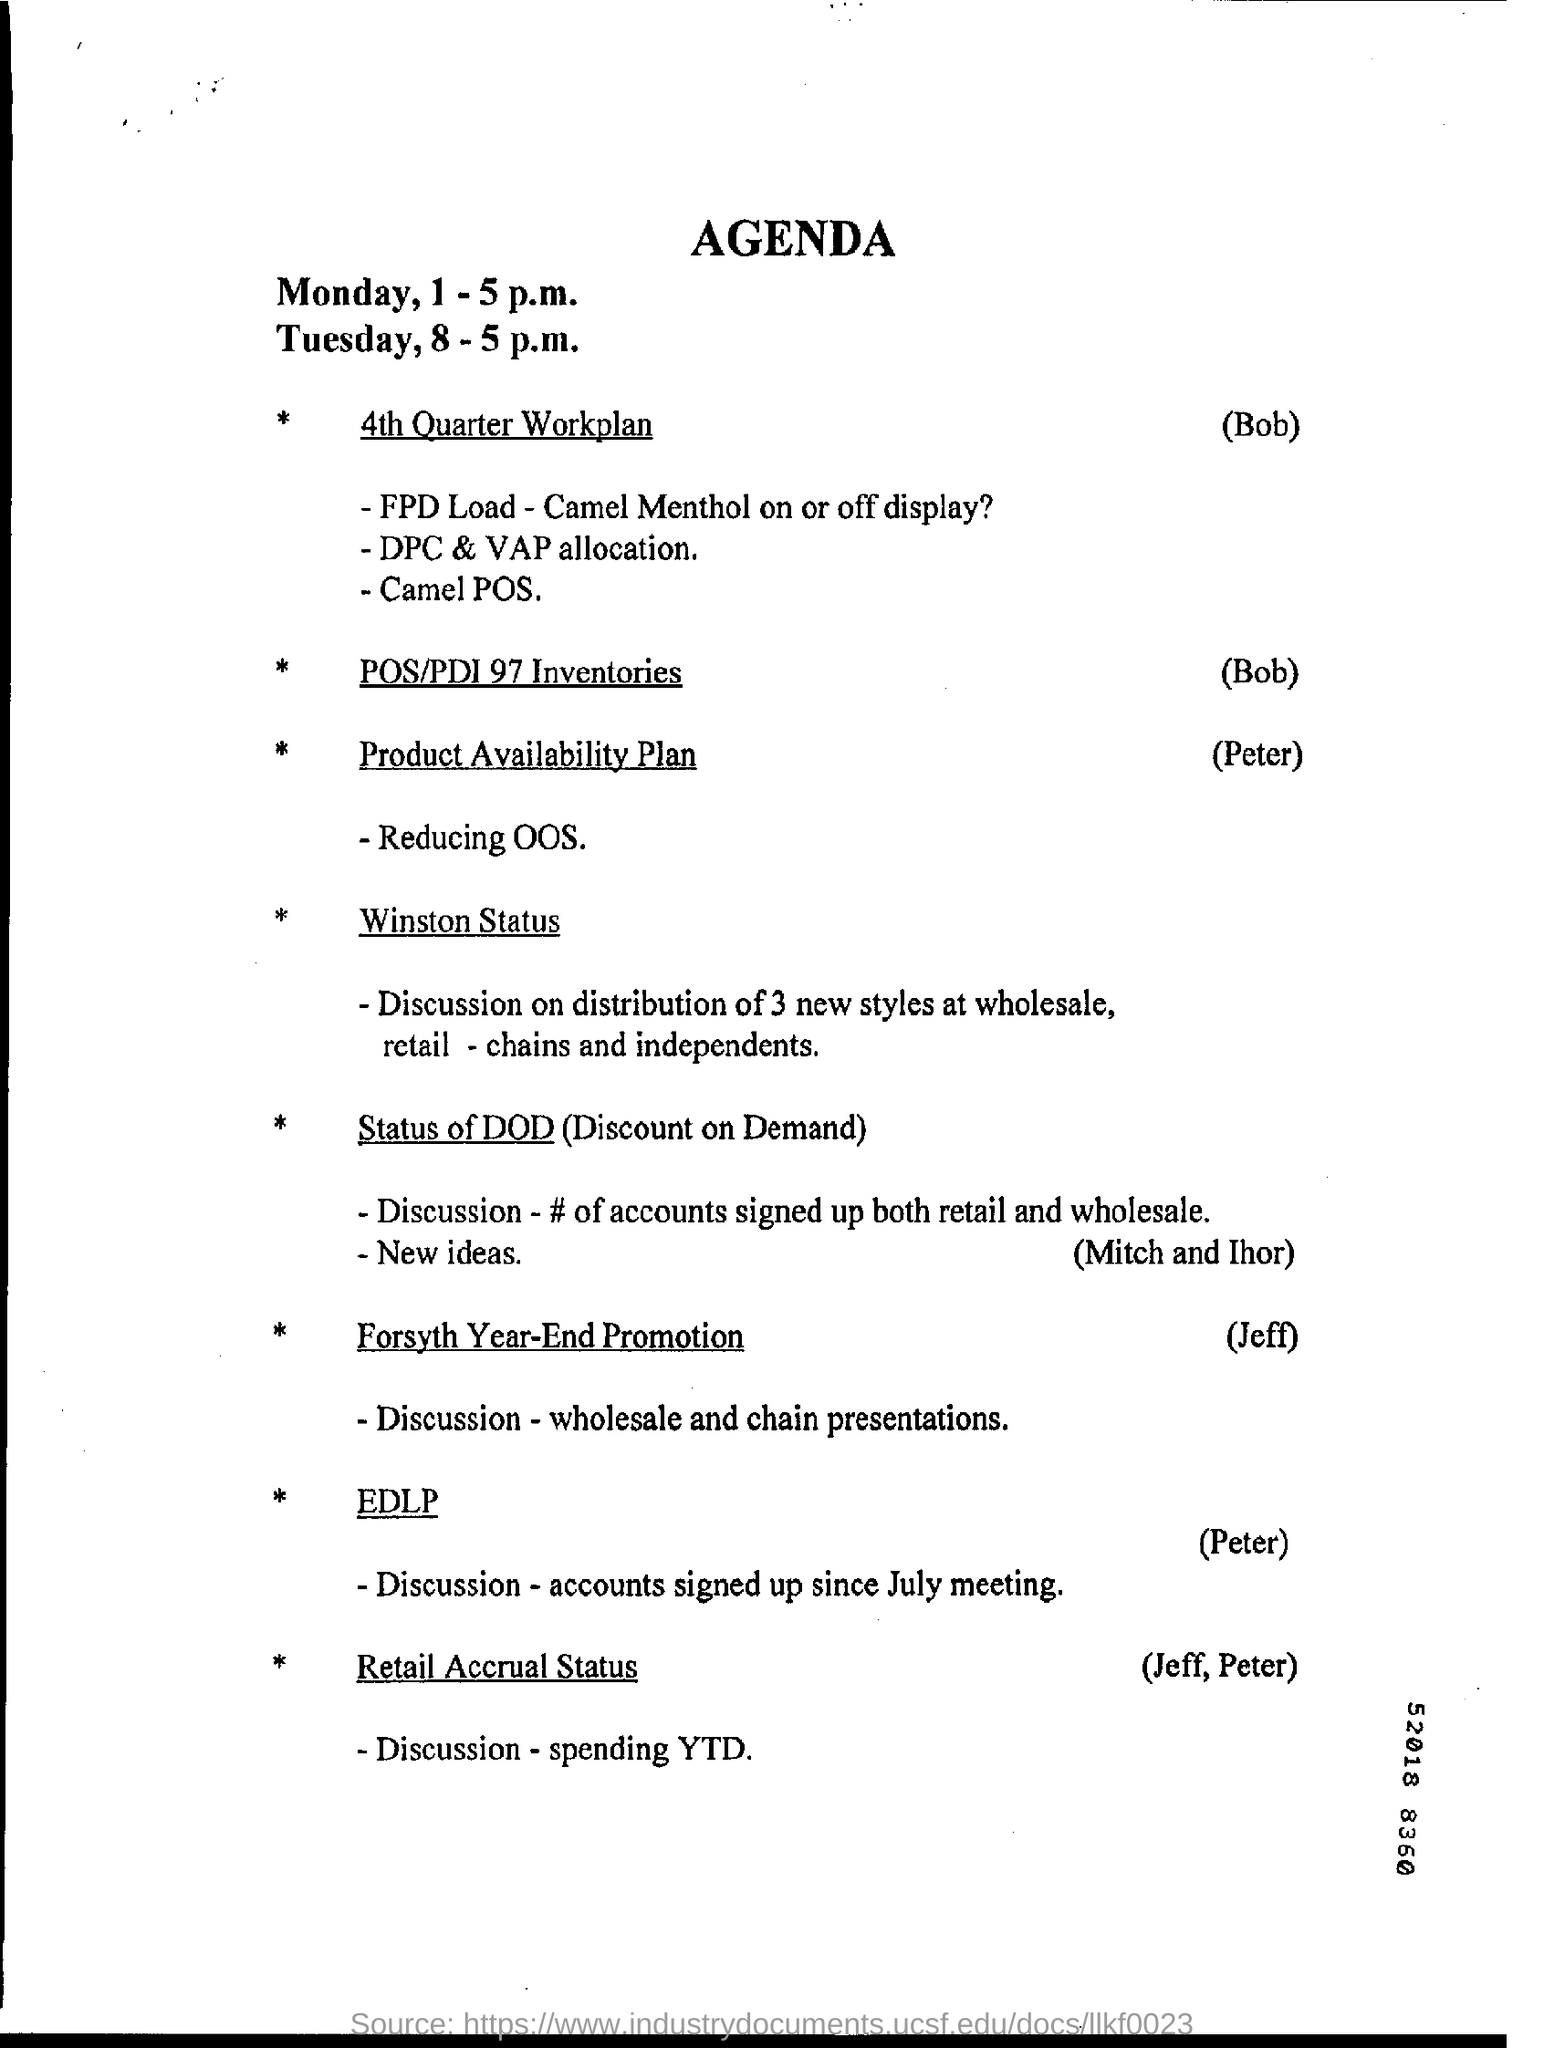Mention a couple of crucial points in this snapshot. The responsibility of explaining the 4th Quarter workplan falls upon Bob. 